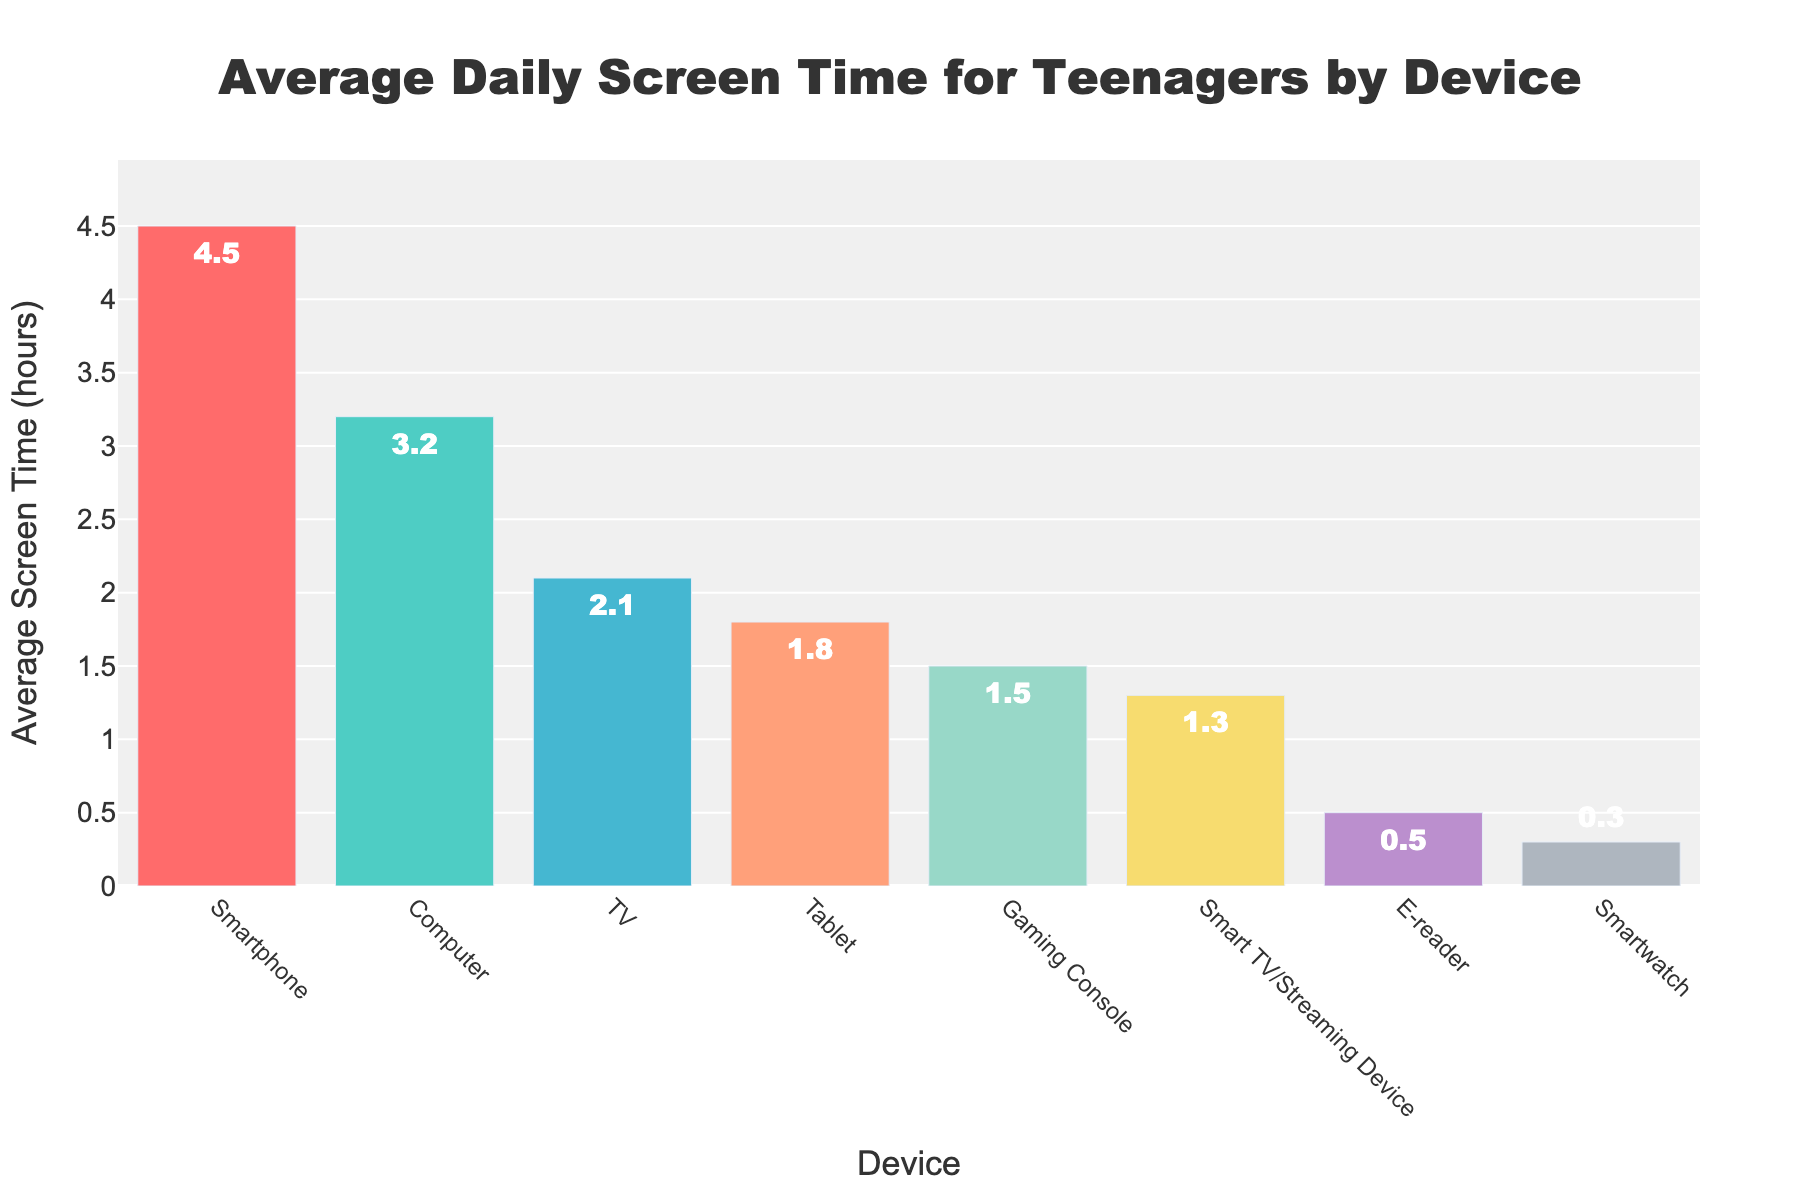Which device has the highest average screen time per day? The bar chart shows that the smartphone has the tallest bar, indicating that it has the highest screen time.
Answer: Smartphone What is the total average screen time for Computer and TV? The average screen time for Computer is 3.2 hours, and for TV, it is 2.1 hours. Adding them together, 3.2 + 2.1 = 5.3 hours.
Answer: 5.3 hours Which device has a higher average screen time: Tablet or Gaming Console? The bar for the Tablet is higher than that for the Gaming Console. The Tablet has 1.8 hours, while the Gaming Console has 1.5 hours.
Answer: Tablet What is the difference in average screen time between the device with the highest and the device with the lowest screen time? The highest average screen time is 4.5 hours for the Smartphone, and the lowest is 0.3 hours for the Smartwatch. The difference is 4.5 - 0.3 = 4.2 hours.
Answer: 4.2 hours How much greater is the average screen time for a Smartphone compared to an E-reader? The average screen time for a Smartphone is 4.5 hours, and for an E-reader, it is 0.5 hours. The difference is 4.5 - 0.5 = 4 hours.
Answer: 4 hours Rank the devices from highest to lowest average screen time. By looking at the heights of the bars from left to right: Smartphone (4.5), Computer (3.2), TV (2.1), Tablet (1.8), Gaming Console (1.5), Smart TV/Streaming Device (1.3), E-reader (0.5), Smartwatch (0.3).
Answer: Smartphone, Computer, TV, Tablet, Gaming Console, Smart TV/Streaming Device, E-reader, Smartwatch Which device has almost half the average screen time of a Tablet? The Tablet has an average screen time of 1.8 hours. Half of 1.8 is 0.9 hours. The Smart TV/Streaming Device has a screen time of 1.3 hours, which is close but not exactly half. No device stands out as having exactly half the time, but this is the closest.
Answer: Not exactly half; closest is Smart TV/Streaming Device 